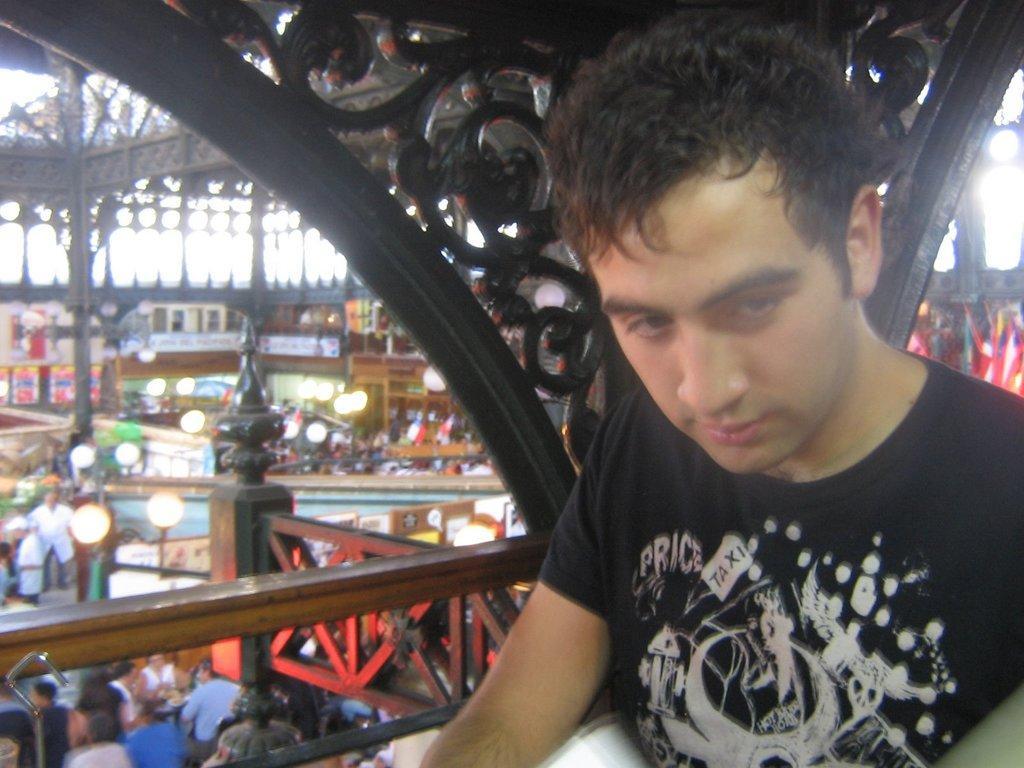Describe this image in one or two sentences. In this image I can see a man. I can see he wearing black t shirt. In background I can see number of lights and I can see few more people. I can also see this image is little bit blurry from background. 